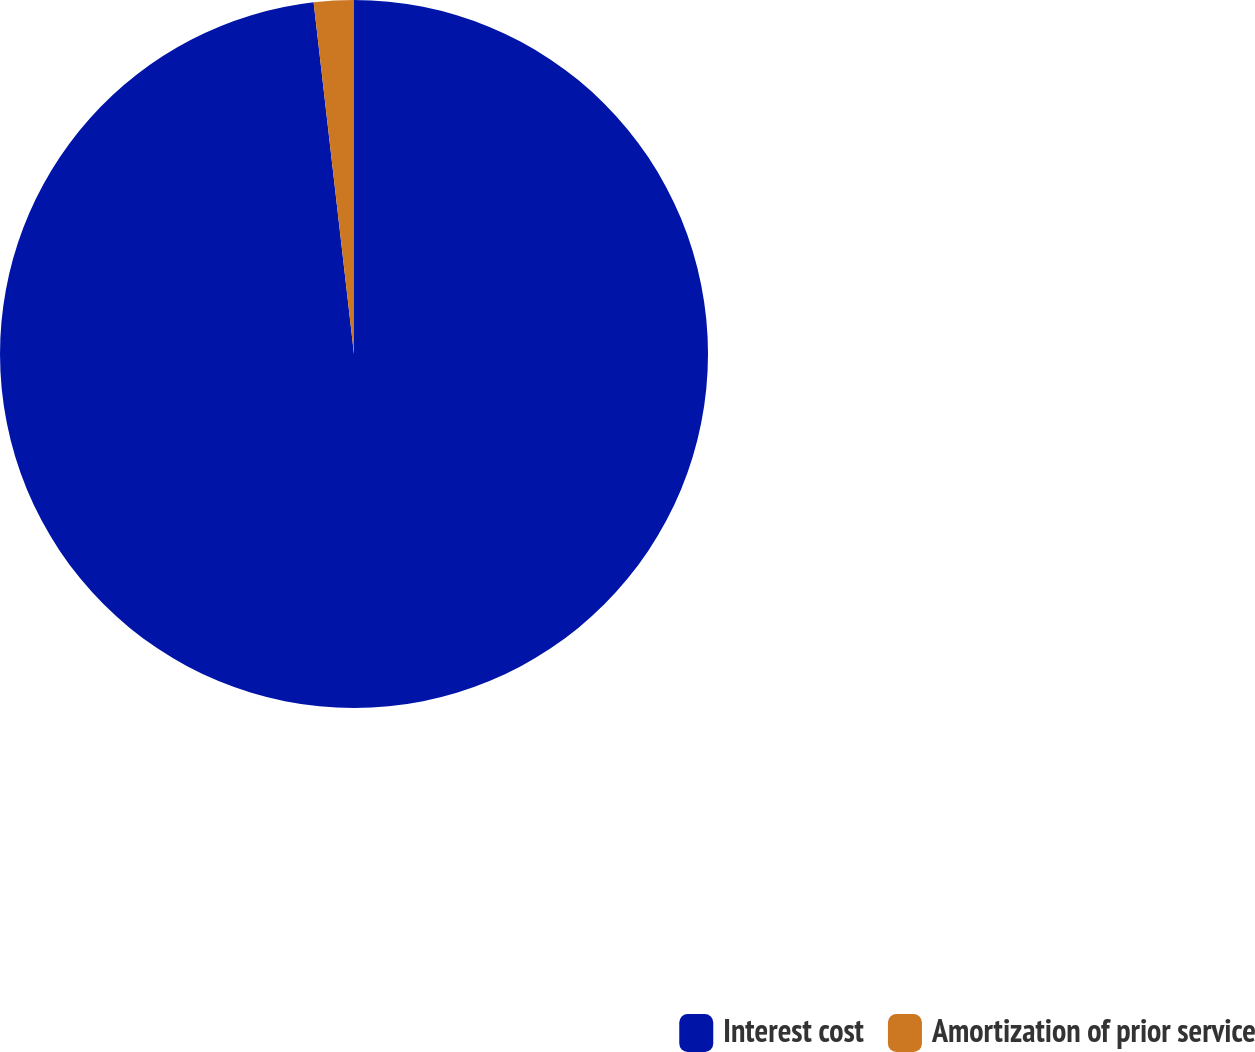Convert chart to OTSL. <chart><loc_0><loc_0><loc_500><loc_500><pie_chart><fcel>Interest cost<fcel>Amortization of prior service<nl><fcel>98.18%<fcel>1.82%<nl></chart> 